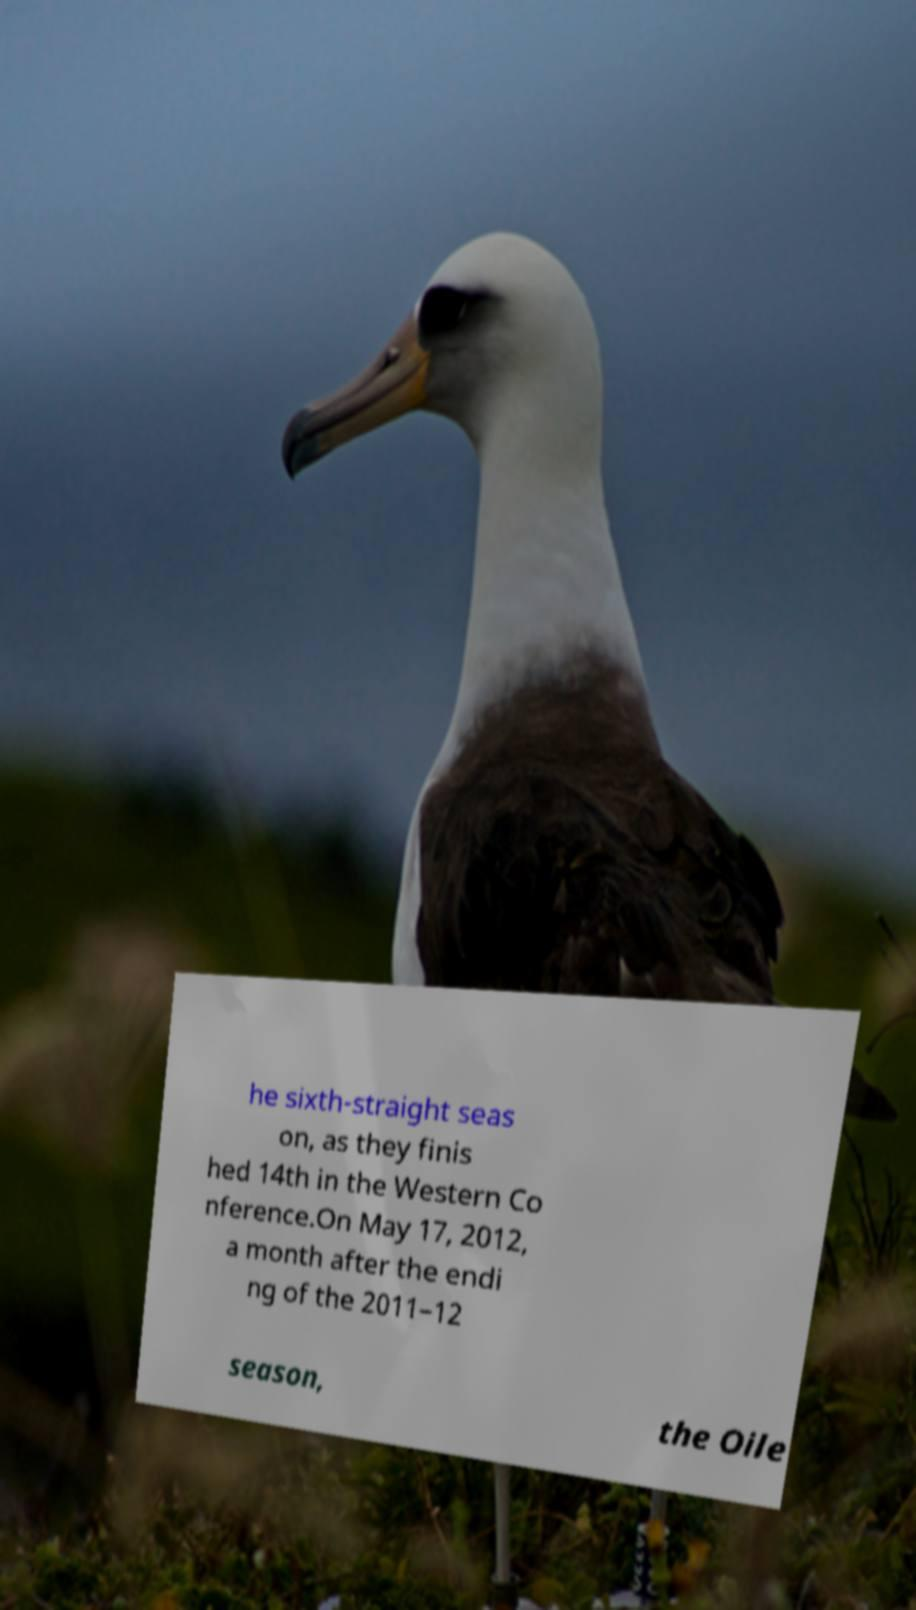For documentation purposes, I need the text within this image transcribed. Could you provide that? he sixth-straight seas on, as they finis hed 14th in the Western Co nference.On May 17, 2012, a month after the endi ng of the 2011–12 season, the Oile 